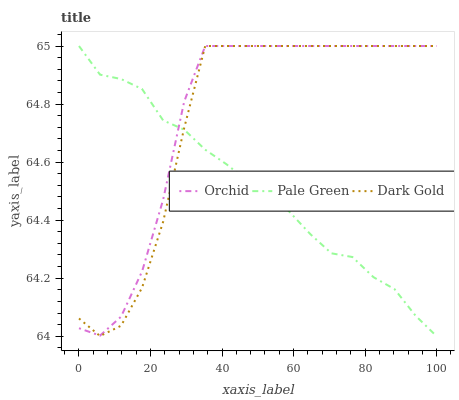Does Pale Green have the minimum area under the curve?
Answer yes or no. Yes. Does Orchid have the maximum area under the curve?
Answer yes or no. Yes. Does Dark Gold have the minimum area under the curve?
Answer yes or no. No. Does Dark Gold have the maximum area under the curve?
Answer yes or no. No. Is Pale Green the smoothest?
Answer yes or no. Yes. Is Dark Gold the roughest?
Answer yes or no. Yes. Is Orchid the smoothest?
Answer yes or no. No. Is Orchid the roughest?
Answer yes or no. No. Does Dark Gold have the lowest value?
Answer yes or no. No. Does Orchid have the highest value?
Answer yes or no. Yes. 